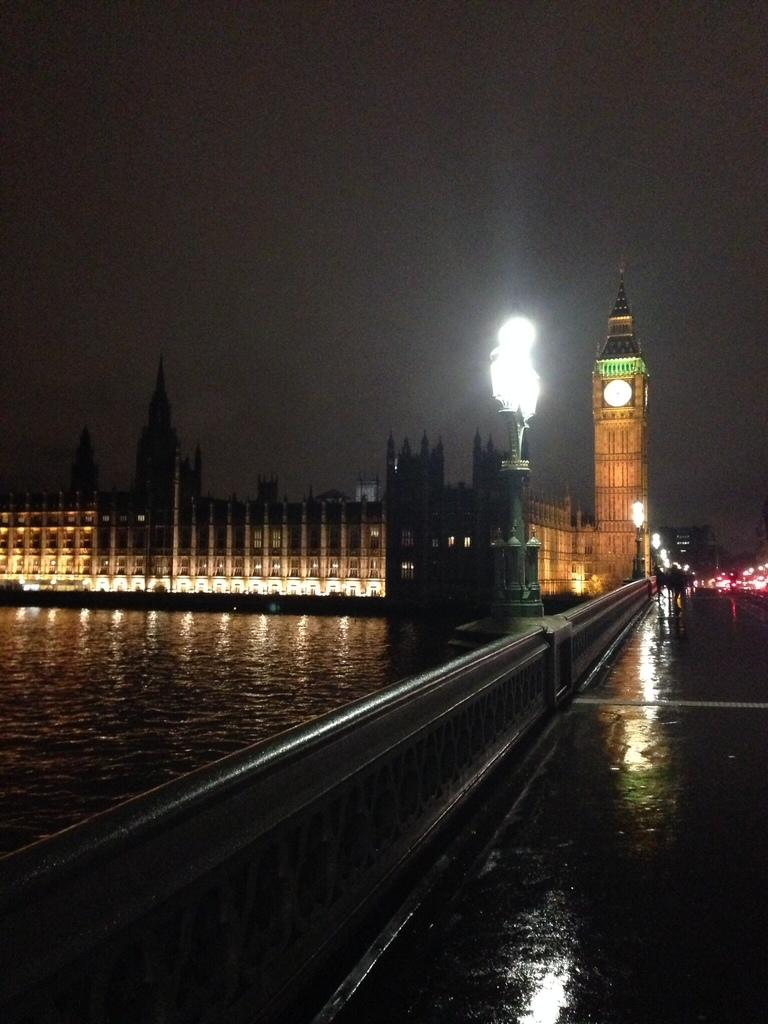What is the primary element present in the image? There is water in the image. What type of structure can be seen in the image? There is a fence in the image. What type of man-made structures are visible in the image? There are buildings visible in the image. What type of illumination is present in the image? There are lights in the image. What type of transportation is visible in the image? There are vehicles on the road in the image. What type of toys can be seen floating in the water in the image? There are no toys present in the image; it only features water, a fence, buildings, lights, and vehicles. 